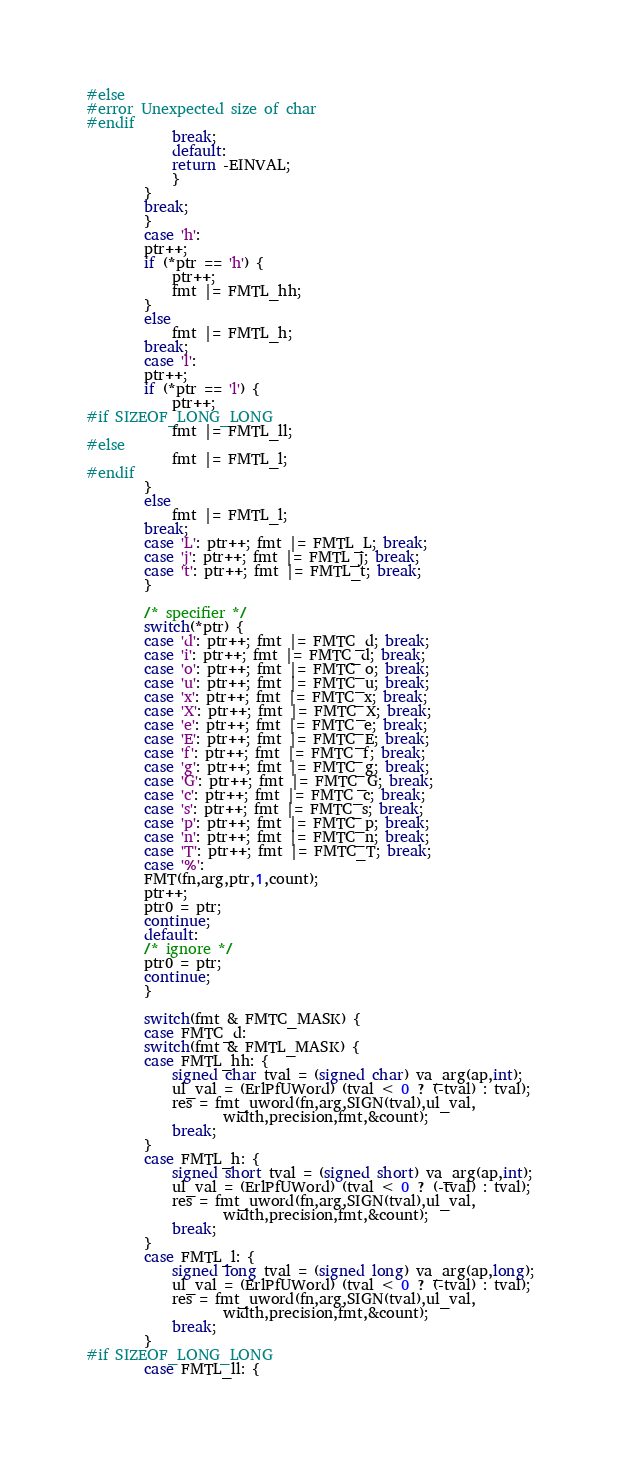Convert code to text. <code><loc_0><loc_0><loc_500><loc_500><_C_>#else
#error Unexpected size of char
#endif
			break;
		    default:
			return -EINVAL;
		    }
		}
		break;
	    }
	    case 'h': 
		ptr++;
		if (*ptr == 'h') {
		    ptr++;
		    fmt |= FMTL_hh;
		}
		else
		    fmt |= FMTL_h;
		break;
	    case 'l':
		ptr++;
		if (*ptr == 'l') {
		    ptr++;
#if SIZEOF_LONG_LONG
		    fmt |= FMTL_ll;
#else
		    fmt |= FMTL_l;
#endif
		}
		else
		    fmt |= FMTL_l;
		break;
	    case 'L': ptr++; fmt |= FMTL_L; break;
	    case 'j': ptr++; fmt |= FMTL_j; break;
	    case 't': ptr++; fmt |= FMTL_t; break;
	    }

	    /* specifier */
	    switch(*ptr) {
	    case 'd': ptr++; fmt |= FMTC_d; break;
	    case 'i': ptr++; fmt |= FMTC_d; break;
	    case 'o': ptr++; fmt |= FMTC_o; break;
	    case 'u': ptr++; fmt |= FMTC_u; break;
	    case 'x': ptr++; fmt |= FMTC_x; break;
	    case 'X': ptr++; fmt |= FMTC_X; break;
	    case 'e': ptr++; fmt |= FMTC_e; break;
	    case 'E': ptr++; fmt |= FMTC_E; break;
	    case 'f': ptr++; fmt |= FMTC_f; break;
	    case 'g': ptr++; fmt |= FMTC_g; break;
	    case 'G': ptr++; fmt |= FMTC_G; break;
	    case 'c': ptr++; fmt |= FMTC_c; break;
	    case 's': ptr++; fmt |= FMTC_s; break;
	    case 'p': ptr++; fmt |= FMTC_p; break;
	    case 'n': ptr++; fmt |= FMTC_n; break;
	    case 'T': ptr++; fmt |= FMTC_T; break;
	    case '%':
		FMT(fn,arg,ptr,1,count);
		ptr++;
		ptr0 = ptr;
		continue;
	    default:
		/* ignore */
		ptr0 = ptr;
		continue;
	    }

	    switch(fmt & FMTC_MASK) {
	    case FMTC_d:
		switch(fmt & FMTL_MASK) {
		case FMTL_hh: {
		    signed char tval = (signed char) va_arg(ap,int);
		    ul_val = (ErlPfUWord) (tval < 0 ? (-tval) : tval);
		    res = fmt_uword(fn,arg,SIGN(tval),ul_val,
				   width,precision,fmt,&count);
		    break;
		}
		case FMTL_h: {
		    signed short tval = (signed short) va_arg(ap,int);
		    ul_val = (ErlPfUWord) (tval < 0 ? (-tval) : tval);
		    res = fmt_uword(fn,arg,SIGN(tval),ul_val,
				   width,precision,fmt,&count);
		    break;
		}
		case FMTL_l: {
		    signed long tval = (signed long) va_arg(ap,long);
		    ul_val = (ErlPfUWord) (tval < 0 ? (-tval) : tval);
		    res = fmt_uword(fn,arg,SIGN(tval),ul_val,
				   width,precision,fmt,&count);
		    break;
		}
#if SIZEOF_LONG_LONG
		case FMTL_ll: {</code> 